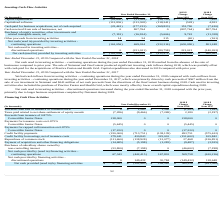According to Allscripts Healthcare Solutions's financial document, What is the Proceeds from sale or issuance of common stock in 2019? According to the financial document, $0 (in thousands). The relevant text states: "2019 $ 2018 $..." Also, What is the Proceeds from sale or issuance of common stock in 2018? According to the financial document, $1,283 (in thousands). The relevant text states: "ceeds from sale or issuance of common stock $ 0 $ 1,283 $ 1,568 $ (1,283) $ (285)..." Also, What is the Proceeds from sale or issuance of common stock in 2017? According to the financial document, $1,568 (in thousands). The relevant text states: "om sale or issuance of common stock $ 0 $ 1,283 $ 1,568 $ (1,283) $ (285)..." Also, can you calculate: What is the change in Taxes paid related to net share settlement of equity awards from 2019 to 2018? Based on the calculation: 7,286-9,466, the result is -2180 (in thousands). This is based on the information: "related to net share settlement of equity awards (7,286) (9,466) (7,269) 2,180 (2,197) to net share settlement of equity awards (7,286) (9,466) (7,269) 2,180 (2,197)..." The key data points involved are: 7,286, 9,466. Also, can you calculate: What is the change in Credit facility payments from 2019 to 2018? Based on the calculation: 220,000-713,751, the result is -493751 (in thousands). This is based on the information: "Credit facility payments (220,000) (713,751) (138,139) 493,751 (575,612) Credit facility payments (220,000) (713,751) (138,139) 493,751 (575,612)..." The key data points involved are: 220,000, 713,751. Also, can you calculate: What is the change in Payment of acquisition and other financing obligations from 2019 to 2018? Based on the calculation: 14,685-5,198, the result is 9487 (in thousands). This is based on the information: "t of acquisition and other financing obligations (14,685) (5,198) (1,283) (9,487) (3,915) isition and other financing obligations (14,685) (5,198) (1,283) (9,487) (3,915)..." The key data points involved are: 14,685, 5,198. 